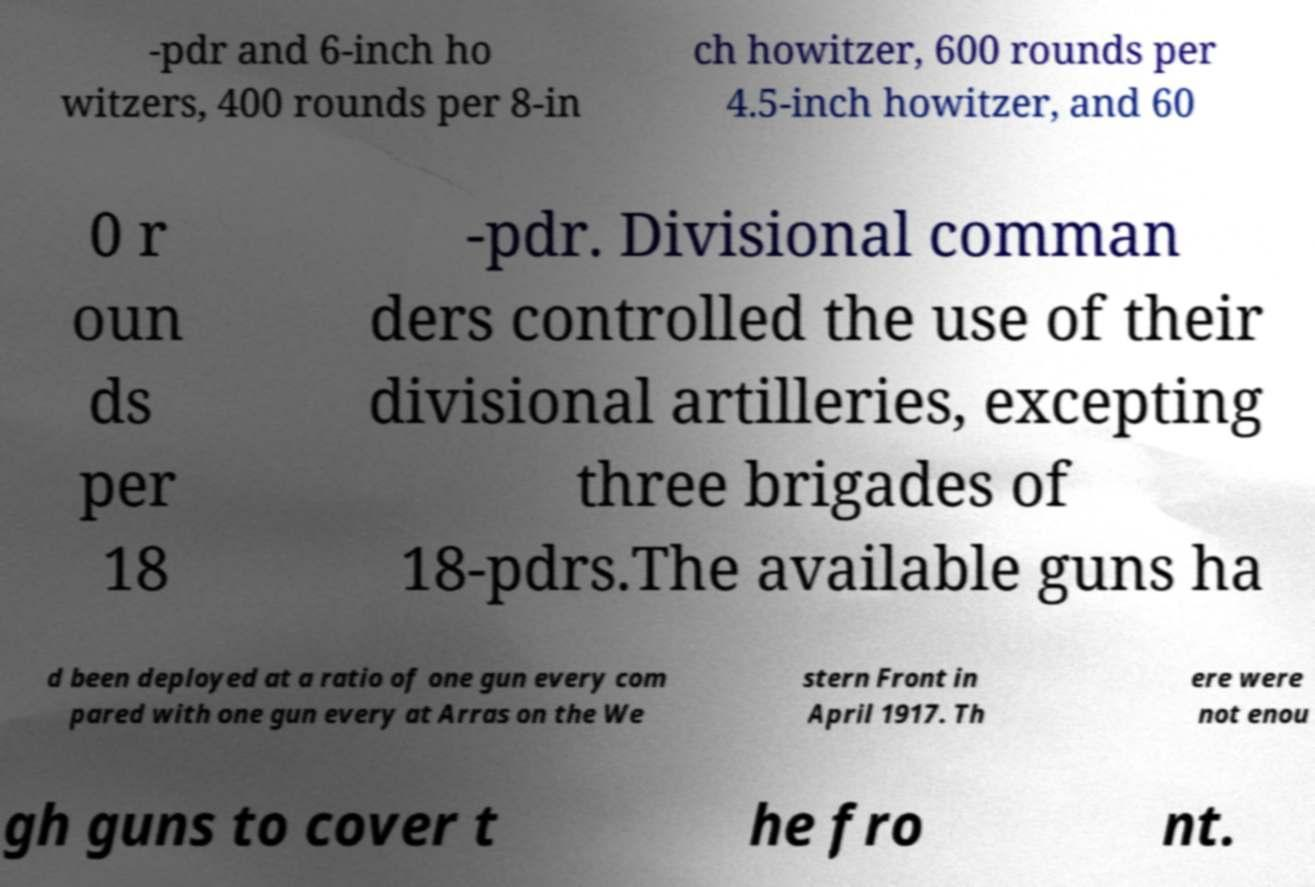Could you assist in decoding the text presented in this image and type it out clearly? -pdr and 6-inch ho witzers, 400 rounds per 8-in ch howitzer, 600 rounds per 4.5-inch howitzer, and 60 0 r oun ds per 18 -pdr. Divisional comman ders controlled the use of their divisional artilleries, excepting three brigades of 18-pdrs.The available guns ha d been deployed at a ratio of one gun every com pared with one gun every at Arras on the We stern Front in April 1917. Th ere were not enou gh guns to cover t he fro nt. 